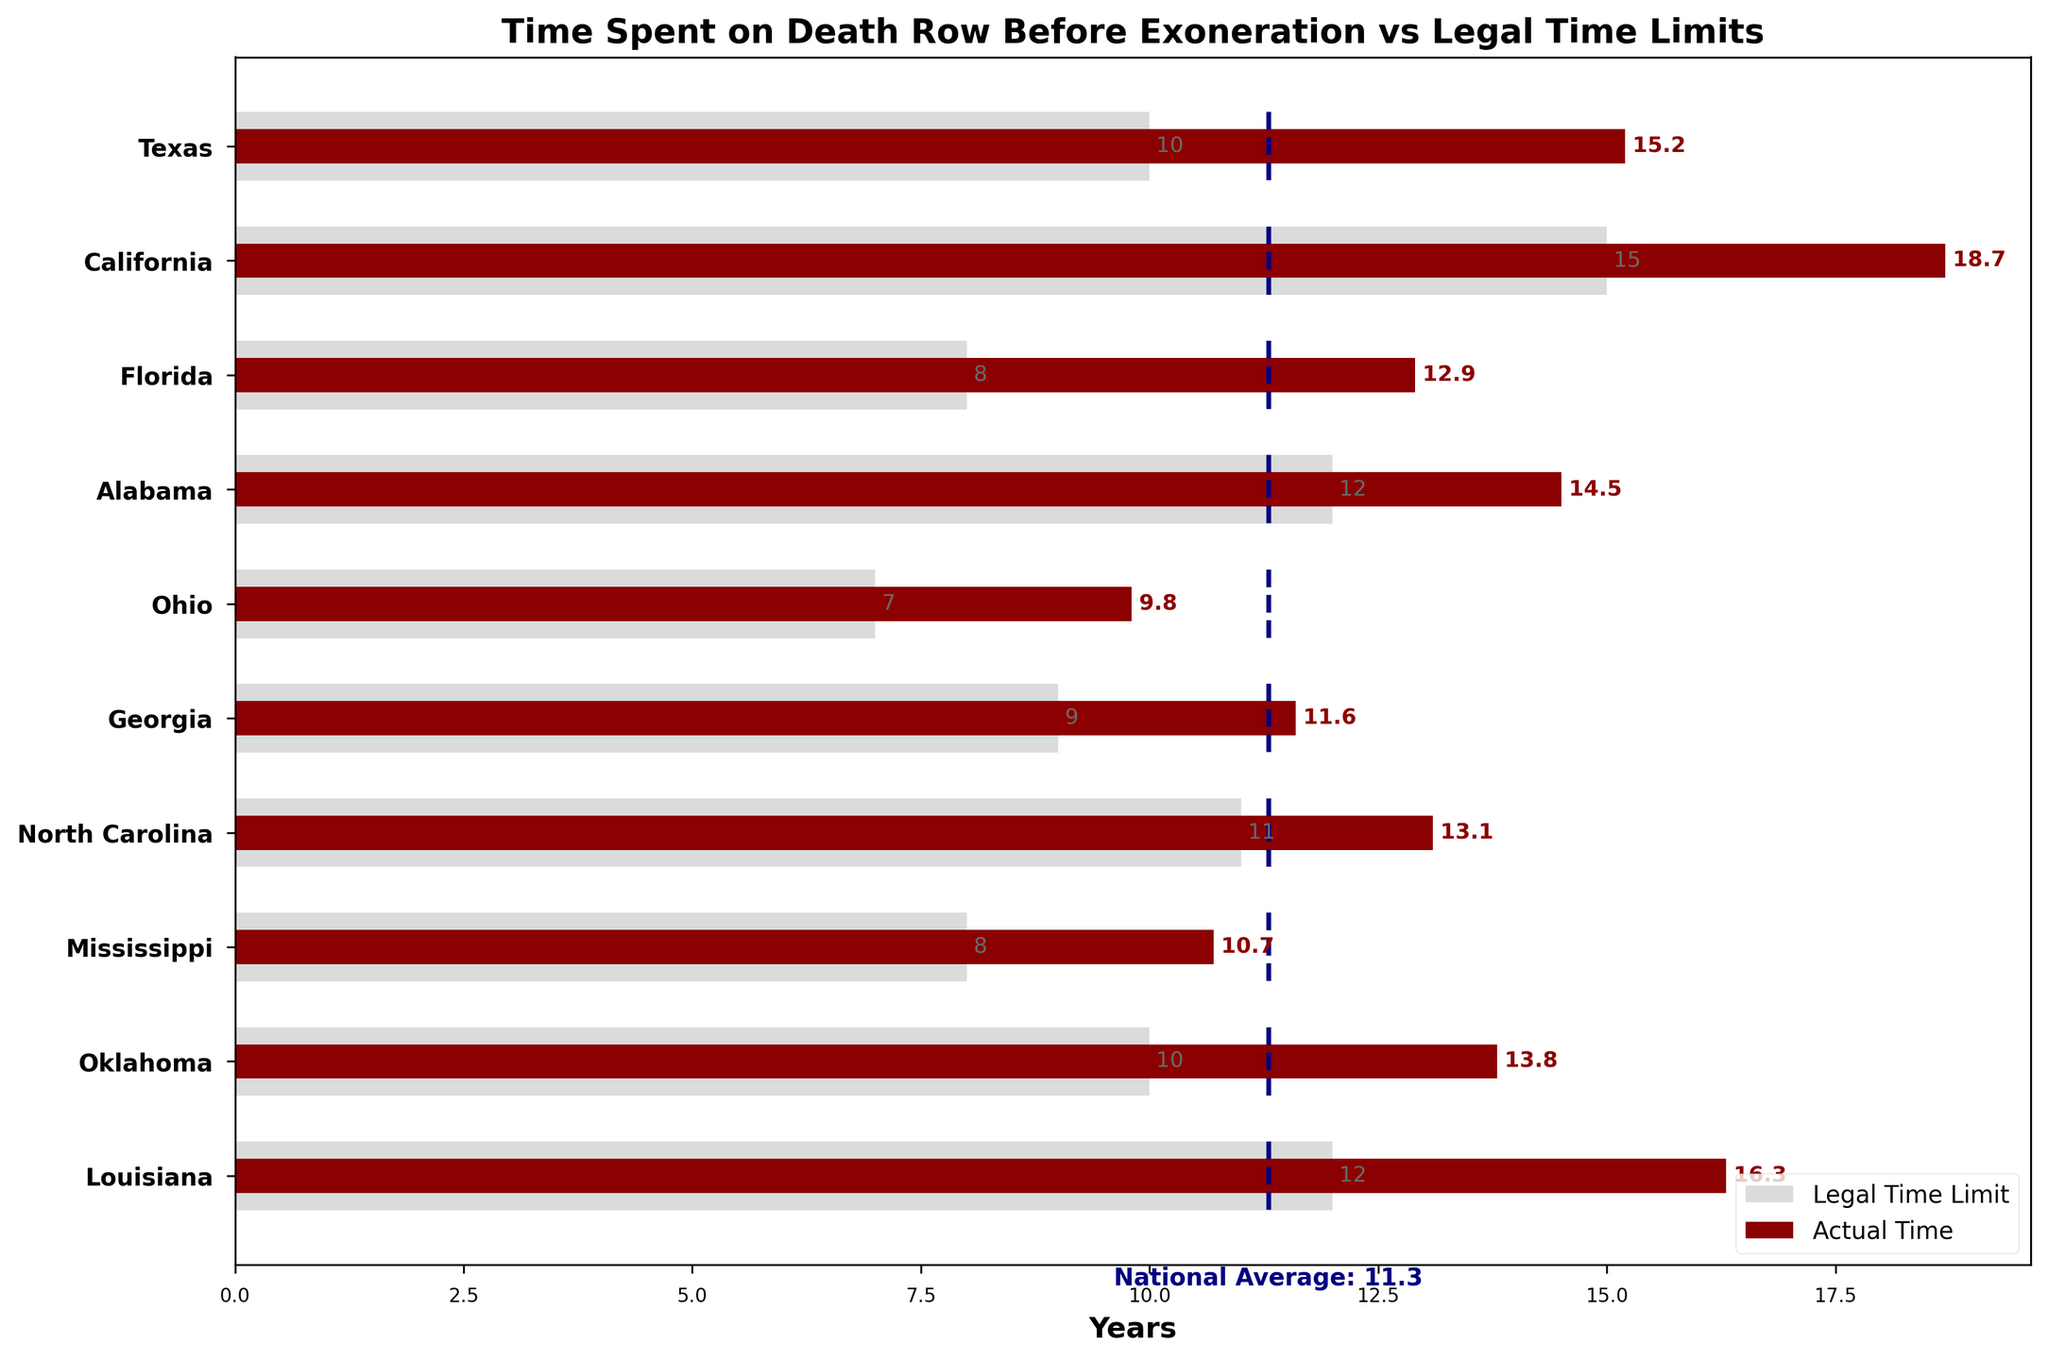What is the title of the chart? The title of the chart is displayed at the top and it reads "Time Spent on Death Row Before Exoneration vs Legal Time Limits".
Answer: Time Spent on Death Row Before Exoneration vs Legal Time Limits Which state has the highest actual time spent on death row before exoneration? By looking at the chart, the state with the longest dark red bar represents the highest actual time. In this case, it is California with an actual time of 18.7 years.
Answer: California What is the national average time spent on death row before exoneration? The national average is indicated by the dotted navy line running through each bar cluster. The annotation at the bottom states the national average is 11.3 years.
Answer: 11.3 years Which state has the lowest legal time limit for death row cases? The state with the shortest light grey bar represents the lowest legal time limit. In this chart, it is Ohio, which has a legal time limit of 7 years.
Answer: Ohio How much longer is California's actual time spent on death row compared to the national average? California's actual time spent on death row is 18.7 years, and the national average is 11.3 years. The difference is calculated as 18.7 - 11.3 = 7.4 years.
Answer: 7.4 years Which states have actual time that exceeds both the legal time limit and the national average? Identify states where the dark red bar (actual time) is longer than both the light grey bar (legal time limit) and the dotted navy line (national average). These states are Texas, California, Alabama, Louisiana, and Oklahoma.
Answer: Texas, California, Alabama, Louisiana, Oklahoma What is the difference in actual time spent on death row between Texas and Ohio? Texas has an actual time of 15.2 years and Ohio has 9.8 years. The difference is calculated as 15.2 - 9.8 = 5.4 years.
Answer: 5.4 years What is the average legal time limit across all the states listed in the chart? Sum the legal time limits of all states and divide by the number of states: (10 + 15 + 8 + 12 + 7 + 9 + 11 + 8 + 10 + 12) / 10 = 10.2 years.
Answer: 10.2 years Which state has the closest actual time spent on death row to the national average? Compare the actual time of each state to the national average (11.3 years) and find the state with the smallest difference. Georgia's actual time is 11.6 years, which is the closest to the national average.
Answer: Georgia For which state(s) is the actual time spent on death row equal to the legal time limit? Find the state(s) where the lengths of the dark red bar (actual time) and the light grey bar (legal time limit) are the same. None of the states have equal actual and legal times on the chart.
Answer: None 